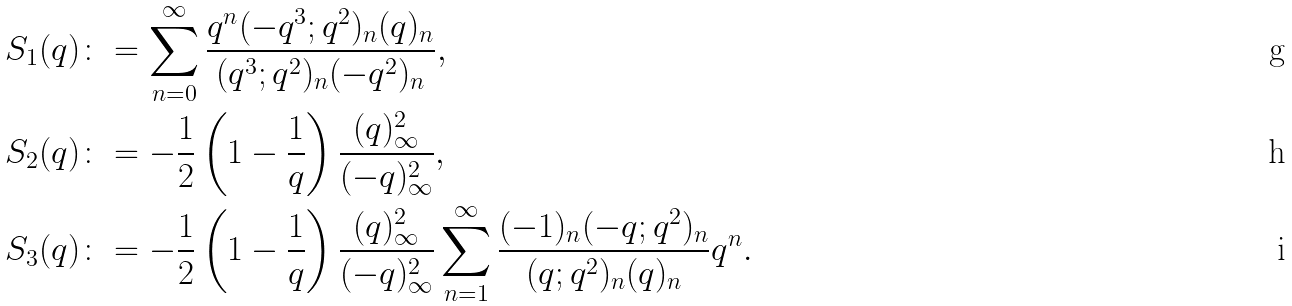<formula> <loc_0><loc_0><loc_500><loc_500>S _ { 1 } ( q ) & \colon = \sum _ { n = 0 } ^ { \infty } \frac { q ^ { n } ( - q ^ { 3 } ; q ^ { 2 } ) _ { n } ( q ) _ { n } } { ( q ^ { 3 } ; q ^ { 2 } ) _ { n } ( - q ^ { 2 } ) _ { n } } , \\ S _ { 2 } ( q ) & \colon = - \frac { 1 } { 2 } \left ( 1 - \frac { 1 } { q } \right ) \frac { ( q ) _ { \infty } ^ { 2 } } { ( - q ) _ { \infty } ^ { 2 } } , \\ S _ { 3 } ( q ) & \colon = - \frac { 1 } { 2 } \left ( 1 - \frac { 1 } { q } \right ) \frac { ( q ) _ { \infty } ^ { 2 } } { ( - q ) _ { \infty } ^ { 2 } } \sum _ { n = 1 } ^ { \infty } \frac { ( - 1 ) _ { n } ( - q ; q ^ { 2 } ) _ { n } } { ( q ; q ^ { 2 } ) _ { n } ( q ) _ { n } } q ^ { n } .</formula> 